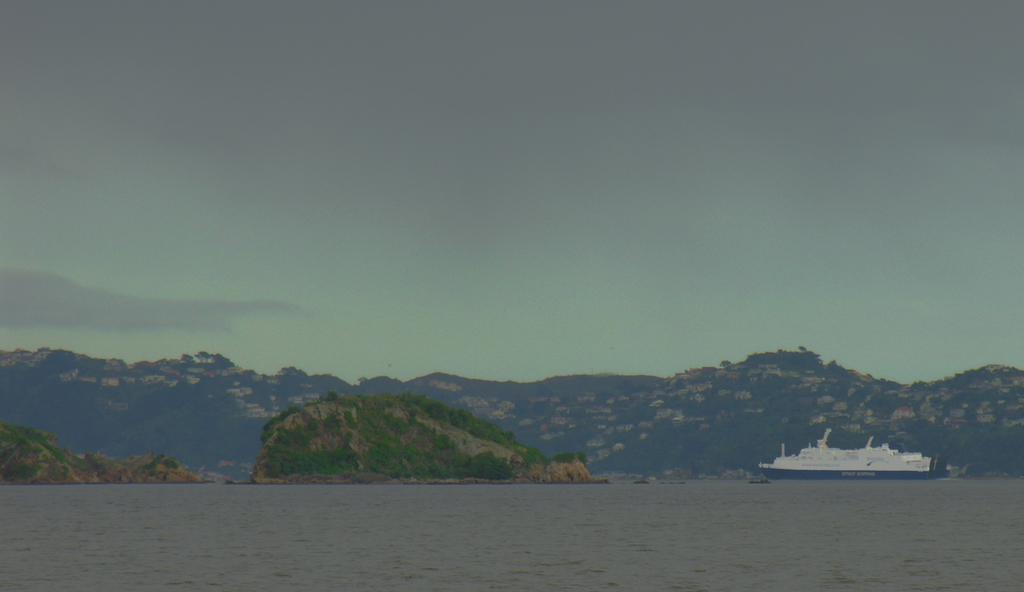Describe this image in one or two sentences. In this image in the front there is water. In the center there is a boat and there are mountains in the background and the sky is cloudy. 